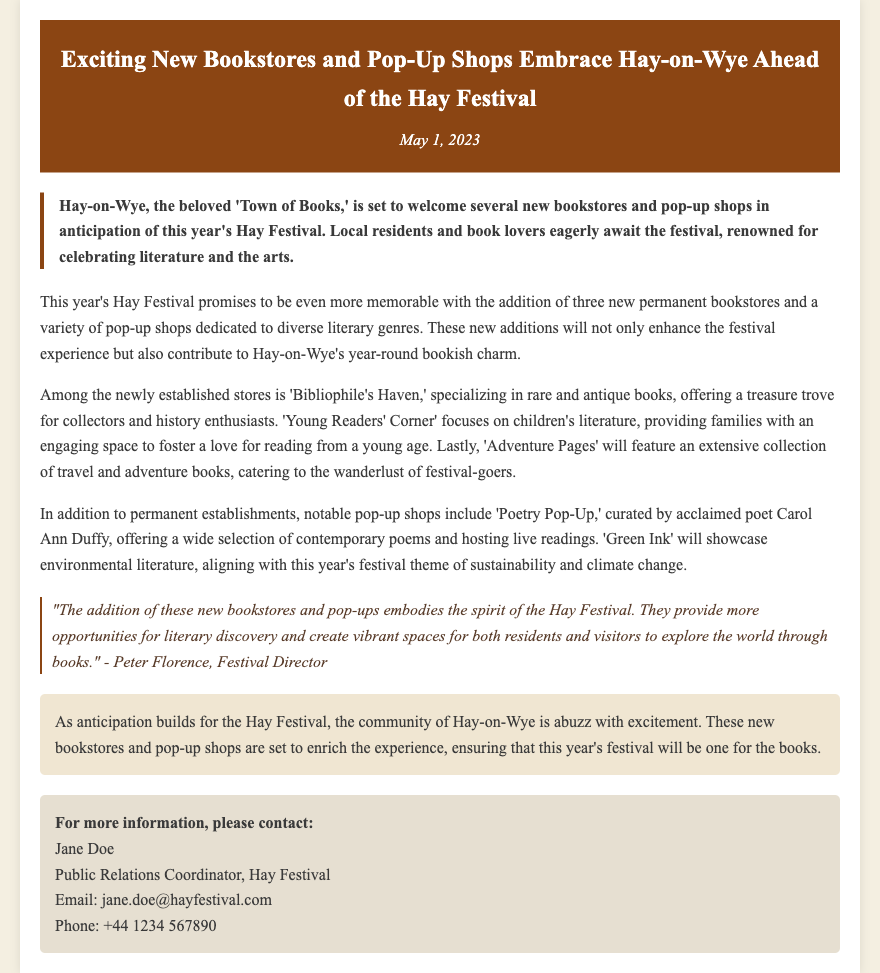What is the date of the press release? The press release is dated May 1, 2023.
Answer: May 1, 2023 How many new permanent bookstores are being added? The document states that there are three new permanent bookstores.
Answer: three What is the name of the bookstore specializing in children's literature? The name of the children's literature bookstore is provided in the document as 'Young Readers' Corner.'
Answer: Young Readers' Corner Who is curating the 'Poetry Pop-Up' shop? The document mentions that the 'Poetry Pop-Up' is curated by Carol Ann Duffy.
Answer: Carol Ann Duffy What theme does this year's festival emphasize? The document notes that the festival theme is sustainability and climate change.
Answer: sustainability and climate change What is the main purpose of the new bookstores and pop-up shops? The purpose is to enhance the festival experience and contribute to Hay-on-Wye's charm.
Answer: enhance the festival experience Who is the Festival Director quoted in the press release? The Festival Director mentioned in the quote is Peter Florence.
Answer: Peter Florence What is the email address of the Public Relations Coordinator? The email address for Jane Doe, the Public Relations Coordinator, is provided in the contact information.
Answer: jane.doe@hayfestival.com 